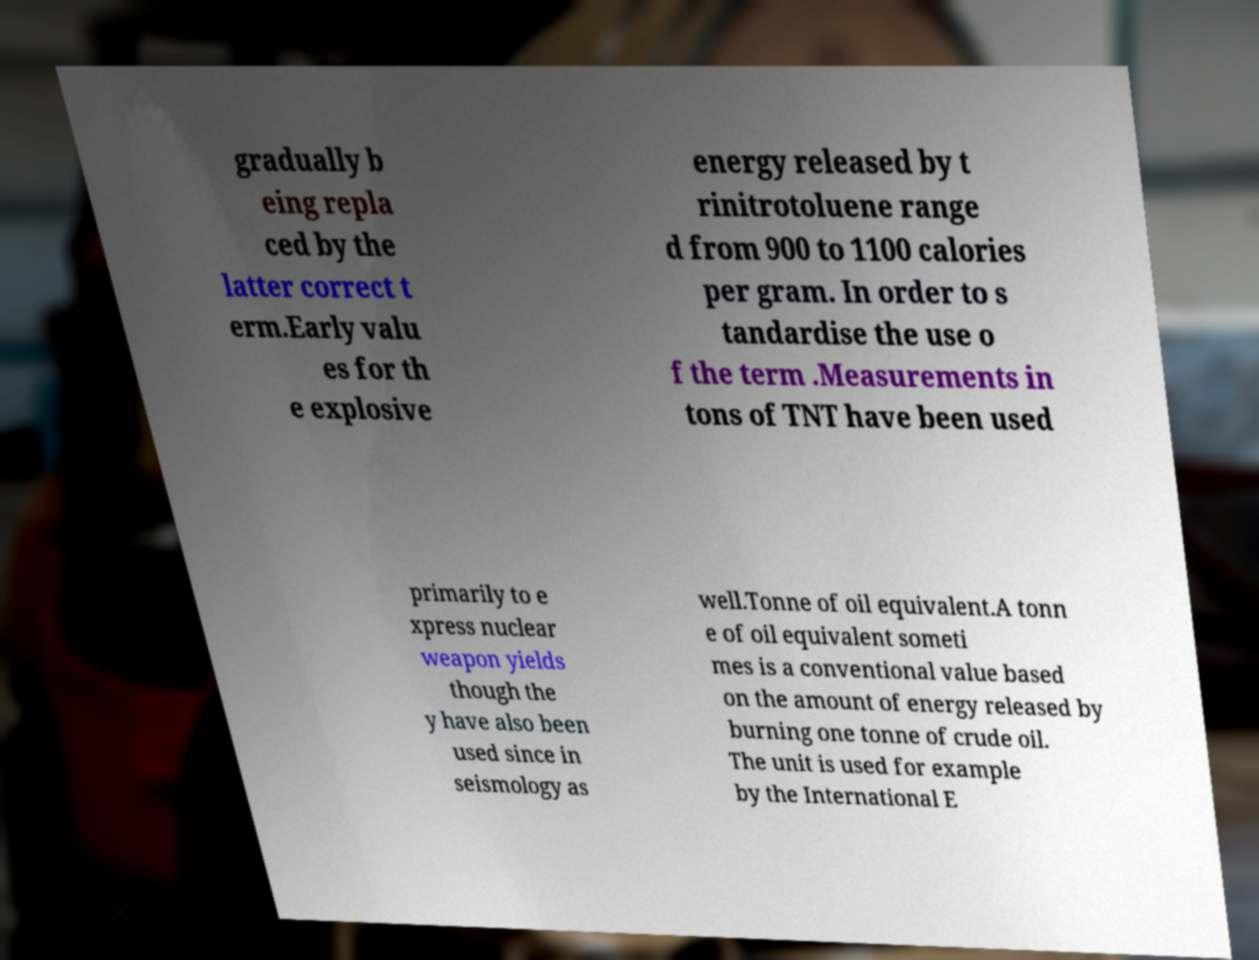Can you accurately transcribe the text from the provided image for me? gradually b eing repla ced by the latter correct t erm.Early valu es for th e explosive energy released by t rinitrotoluene range d from 900 to 1100 calories per gram. In order to s tandardise the use o f the term .Measurements in tons of TNT have been used primarily to e xpress nuclear weapon yields though the y have also been used since in seismology as well.Tonne of oil equivalent.A tonn e of oil equivalent someti mes is a conventional value based on the amount of energy released by burning one tonne of crude oil. The unit is used for example by the International E 